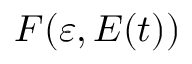Convert formula to latex. <formula><loc_0><loc_0><loc_500><loc_500>F ( \varepsilon , E ( t ) )</formula> 